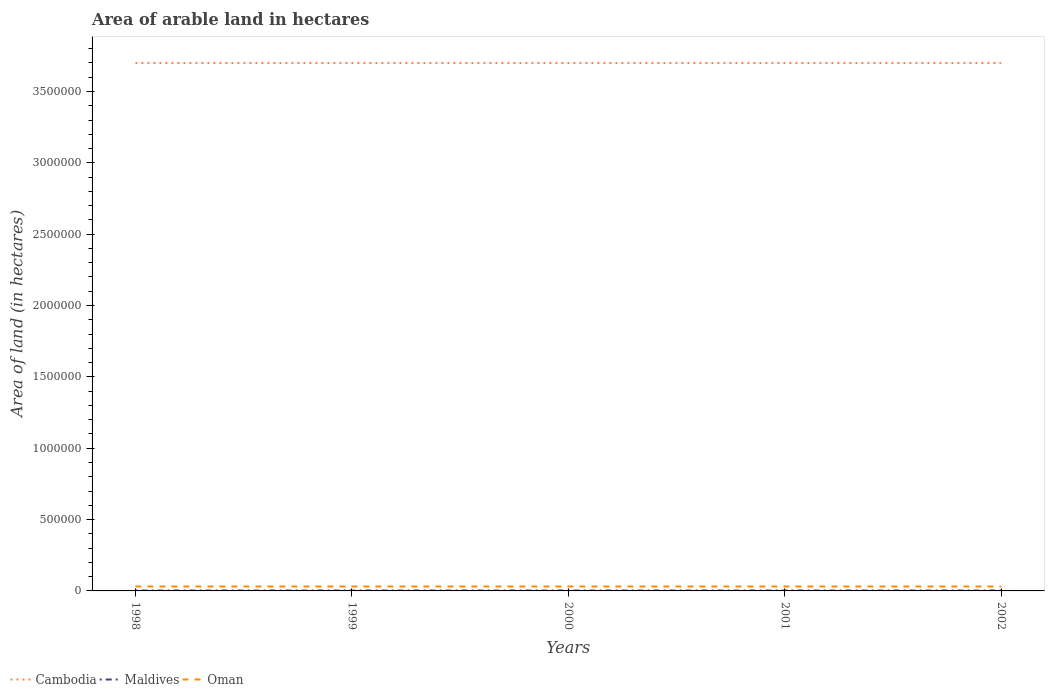Does the line corresponding to Maldives intersect with the line corresponding to Cambodia?
Make the answer very short. No. Is the number of lines equal to the number of legend labels?
Offer a terse response. Yes. Across all years, what is the maximum total arable land in Maldives?
Your answer should be compact. 3000. In which year was the total arable land in Oman maximum?
Provide a short and direct response. 1998. What is the difference between the highest and the second highest total arable land in Maldives?
Ensure brevity in your answer.  0. What is the difference between the highest and the lowest total arable land in Cambodia?
Your answer should be very brief. 0. Is the total arable land in Maldives strictly greater than the total arable land in Oman over the years?
Give a very brief answer. Yes. How many lines are there?
Provide a succinct answer. 3. How many years are there in the graph?
Make the answer very short. 5. What is the difference between two consecutive major ticks on the Y-axis?
Keep it short and to the point. 5.00e+05. Are the values on the major ticks of Y-axis written in scientific E-notation?
Give a very brief answer. No. Where does the legend appear in the graph?
Ensure brevity in your answer.  Bottom left. What is the title of the graph?
Provide a succinct answer. Area of arable land in hectares. What is the label or title of the X-axis?
Provide a short and direct response. Years. What is the label or title of the Y-axis?
Offer a very short reply. Area of land (in hectares). What is the Area of land (in hectares) in Cambodia in 1998?
Provide a succinct answer. 3.70e+06. What is the Area of land (in hectares) in Maldives in 1998?
Give a very brief answer. 3000. What is the Area of land (in hectares) of Oman in 1998?
Offer a very short reply. 3.10e+04. What is the Area of land (in hectares) in Cambodia in 1999?
Make the answer very short. 3.70e+06. What is the Area of land (in hectares) of Maldives in 1999?
Provide a short and direct response. 3000. What is the Area of land (in hectares) in Oman in 1999?
Make the answer very short. 3.10e+04. What is the Area of land (in hectares) of Cambodia in 2000?
Offer a very short reply. 3.70e+06. What is the Area of land (in hectares) of Maldives in 2000?
Give a very brief answer. 3000. What is the Area of land (in hectares) of Oman in 2000?
Your answer should be compact. 3.10e+04. What is the Area of land (in hectares) of Cambodia in 2001?
Provide a succinct answer. 3.70e+06. What is the Area of land (in hectares) in Maldives in 2001?
Ensure brevity in your answer.  3000. What is the Area of land (in hectares) in Oman in 2001?
Provide a succinct answer. 3.10e+04. What is the Area of land (in hectares) of Cambodia in 2002?
Offer a very short reply. 3.70e+06. What is the Area of land (in hectares) in Maldives in 2002?
Keep it short and to the point. 3000. What is the Area of land (in hectares) of Oman in 2002?
Your answer should be very brief. 3.10e+04. Across all years, what is the maximum Area of land (in hectares) in Cambodia?
Offer a very short reply. 3.70e+06. Across all years, what is the maximum Area of land (in hectares) in Maldives?
Provide a succinct answer. 3000. Across all years, what is the maximum Area of land (in hectares) in Oman?
Offer a very short reply. 3.10e+04. Across all years, what is the minimum Area of land (in hectares) of Cambodia?
Give a very brief answer. 3.70e+06. Across all years, what is the minimum Area of land (in hectares) in Maldives?
Your answer should be compact. 3000. Across all years, what is the minimum Area of land (in hectares) in Oman?
Your answer should be compact. 3.10e+04. What is the total Area of land (in hectares) in Cambodia in the graph?
Offer a very short reply. 1.85e+07. What is the total Area of land (in hectares) in Maldives in the graph?
Ensure brevity in your answer.  1.50e+04. What is the total Area of land (in hectares) of Oman in the graph?
Provide a short and direct response. 1.55e+05. What is the difference between the Area of land (in hectares) of Cambodia in 1998 and that in 1999?
Your answer should be very brief. 0. What is the difference between the Area of land (in hectares) in Maldives in 1998 and that in 1999?
Keep it short and to the point. 0. What is the difference between the Area of land (in hectares) of Cambodia in 1998 and that in 2000?
Offer a terse response. 0. What is the difference between the Area of land (in hectares) in Maldives in 1998 and that in 2000?
Your answer should be very brief. 0. What is the difference between the Area of land (in hectares) in Cambodia in 1998 and that in 2001?
Your response must be concise. 0. What is the difference between the Area of land (in hectares) in Maldives in 1998 and that in 2001?
Give a very brief answer. 0. What is the difference between the Area of land (in hectares) in Oman in 1998 and that in 2001?
Offer a terse response. 0. What is the difference between the Area of land (in hectares) of Cambodia in 1999 and that in 2000?
Give a very brief answer. 0. What is the difference between the Area of land (in hectares) of Oman in 1999 and that in 2000?
Offer a terse response. 0. What is the difference between the Area of land (in hectares) of Maldives in 1999 and that in 2001?
Ensure brevity in your answer.  0. What is the difference between the Area of land (in hectares) of Maldives in 1999 and that in 2002?
Provide a succinct answer. 0. What is the difference between the Area of land (in hectares) in Cambodia in 2000 and that in 2001?
Your answer should be very brief. 0. What is the difference between the Area of land (in hectares) of Maldives in 2000 and that in 2001?
Provide a succinct answer. 0. What is the difference between the Area of land (in hectares) in Oman in 2000 and that in 2002?
Your answer should be compact. 0. What is the difference between the Area of land (in hectares) in Cambodia in 1998 and the Area of land (in hectares) in Maldives in 1999?
Offer a very short reply. 3.70e+06. What is the difference between the Area of land (in hectares) of Cambodia in 1998 and the Area of land (in hectares) of Oman in 1999?
Give a very brief answer. 3.67e+06. What is the difference between the Area of land (in hectares) of Maldives in 1998 and the Area of land (in hectares) of Oman in 1999?
Provide a succinct answer. -2.80e+04. What is the difference between the Area of land (in hectares) of Cambodia in 1998 and the Area of land (in hectares) of Maldives in 2000?
Keep it short and to the point. 3.70e+06. What is the difference between the Area of land (in hectares) in Cambodia in 1998 and the Area of land (in hectares) in Oman in 2000?
Offer a very short reply. 3.67e+06. What is the difference between the Area of land (in hectares) of Maldives in 1998 and the Area of land (in hectares) of Oman in 2000?
Your answer should be compact. -2.80e+04. What is the difference between the Area of land (in hectares) of Cambodia in 1998 and the Area of land (in hectares) of Maldives in 2001?
Provide a succinct answer. 3.70e+06. What is the difference between the Area of land (in hectares) in Cambodia in 1998 and the Area of land (in hectares) in Oman in 2001?
Your answer should be very brief. 3.67e+06. What is the difference between the Area of land (in hectares) in Maldives in 1998 and the Area of land (in hectares) in Oman in 2001?
Your answer should be very brief. -2.80e+04. What is the difference between the Area of land (in hectares) in Cambodia in 1998 and the Area of land (in hectares) in Maldives in 2002?
Offer a very short reply. 3.70e+06. What is the difference between the Area of land (in hectares) in Cambodia in 1998 and the Area of land (in hectares) in Oman in 2002?
Provide a succinct answer. 3.67e+06. What is the difference between the Area of land (in hectares) in Maldives in 1998 and the Area of land (in hectares) in Oman in 2002?
Provide a short and direct response. -2.80e+04. What is the difference between the Area of land (in hectares) in Cambodia in 1999 and the Area of land (in hectares) in Maldives in 2000?
Provide a succinct answer. 3.70e+06. What is the difference between the Area of land (in hectares) in Cambodia in 1999 and the Area of land (in hectares) in Oman in 2000?
Keep it short and to the point. 3.67e+06. What is the difference between the Area of land (in hectares) of Maldives in 1999 and the Area of land (in hectares) of Oman in 2000?
Keep it short and to the point. -2.80e+04. What is the difference between the Area of land (in hectares) in Cambodia in 1999 and the Area of land (in hectares) in Maldives in 2001?
Your response must be concise. 3.70e+06. What is the difference between the Area of land (in hectares) of Cambodia in 1999 and the Area of land (in hectares) of Oman in 2001?
Ensure brevity in your answer.  3.67e+06. What is the difference between the Area of land (in hectares) of Maldives in 1999 and the Area of land (in hectares) of Oman in 2001?
Make the answer very short. -2.80e+04. What is the difference between the Area of land (in hectares) in Cambodia in 1999 and the Area of land (in hectares) in Maldives in 2002?
Your response must be concise. 3.70e+06. What is the difference between the Area of land (in hectares) of Cambodia in 1999 and the Area of land (in hectares) of Oman in 2002?
Your response must be concise. 3.67e+06. What is the difference between the Area of land (in hectares) in Maldives in 1999 and the Area of land (in hectares) in Oman in 2002?
Give a very brief answer. -2.80e+04. What is the difference between the Area of land (in hectares) in Cambodia in 2000 and the Area of land (in hectares) in Maldives in 2001?
Offer a very short reply. 3.70e+06. What is the difference between the Area of land (in hectares) of Cambodia in 2000 and the Area of land (in hectares) of Oman in 2001?
Give a very brief answer. 3.67e+06. What is the difference between the Area of land (in hectares) of Maldives in 2000 and the Area of land (in hectares) of Oman in 2001?
Keep it short and to the point. -2.80e+04. What is the difference between the Area of land (in hectares) in Cambodia in 2000 and the Area of land (in hectares) in Maldives in 2002?
Provide a short and direct response. 3.70e+06. What is the difference between the Area of land (in hectares) of Cambodia in 2000 and the Area of land (in hectares) of Oman in 2002?
Your answer should be very brief. 3.67e+06. What is the difference between the Area of land (in hectares) in Maldives in 2000 and the Area of land (in hectares) in Oman in 2002?
Offer a terse response. -2.80e+04. What is the difference between the Area of land (in hectares) of Cambodia in 2001 and the Area of land (in hectares) of Maldives in 2002?
Offer a terse response. 3.70e+06. What is the difference between the Area of land (in hectares) of Cambodia in 2001 and the Area of land (in hectares) of Oman in 2002?
Provide a short and direct response. 3.67e+06. What is the difference between the Area of land (in hectares) in Maldives in 2001 and the Area of land (in hectares) in Oman in 2002?
Give a very brief answer. -2.80e+04. What is the average Area of land (in hectares) in Cambodia per year?
Ensure brevity in your answer.  3.70e+06. What is the average Area of land (in hectares) of Maldives per year?
Your response must be concise. 3000. What is the average Area of land (in hectares) in Oman per year?
Provide a succinct answer. 3.10e+04. In the year 1998, what is the difference between the Area of land (in hectares) in Cambodia and Area of land (in hectares) in Maldives?
Provide a succinct answer. 3.70e+06. In the year 1998, what is the difference between the Area of land (in hectares) of Cambodia and Area of land (in hectares) of Oman?
Provide a short and direct response. 3.67e+06. In the year 1998, what is the difference between the Area of land (in hectares) of Maldives and Area of land (in hectares) of Oman?
Offer a very short reply. -2.80e+04. In the year 1999, what is the difference between the Area of land (in hectares) in Cambodia and Area of land (in hectares) in Maldives?
Give a very brief answer. 3.70e+06. In the year 1999, what is the difference between the Area of land (in hectares) of Cambodia and Area of land (in hectares) of Oman?
Your answer should be very brief. 3.67e+06. In the year 1999, what is the difference between the Area of land (in hectares) in Maldives and Area of land (in hectares) in Oman?
Provide a short and direct response. -2.80e+04. In the year 2000, what is the difference between the Area of land (in hectares) of Cambodia and Area of land (in hectares) of Maldives?
Make the answer very short. 3.70e+06. In the year 2000, what is the difference between the Area of land (in hectares) in Cambodia and Area of land (in hectares) in Oman?
Make the answer very short. 3.67e+06. In the year 2000, what is the difference between the Area of land (in hectares) of Maldives and Area of land (in hectares) of Oman?
Make the answer very short. -2.80e+04. In the year 2001, what is the difference between the Area of land (in hectares) in Cambodia and Area of land (in hectares) in Maldives?
Your answer should be compact. 3.70e+06. In the year 2001, what is the difference between the Area of land (in hectares) in Cambodia and Area of land (in hectares) in Oman?
Your answer should be very brief. 3.67e+06. In the year 2001, what is the difference between the Area of land (in hectares) of Maldives and Area of land (in hectares) of Oman?
Offer a very short reply. -2.80e+04. In the year 2002, what is the difference between the Area of land (in hectares) of Cambodia and Area of land (in hectares) of Maldives?
Make the answer very short. 3.70e+06. In the year 2002, what is the difference between the Area of land (in hectares) in Cambodia and Area of land (in hectares) in Oman?
Make the answer very short. 3.67e+06. In the year 2002, what is the difference between the Area of land (in hectares) of Maldives and Area of land (in hectares) of Oman?
Offer a very short reply. -2.80e+04. What is the ratio of the Area of land (in hectares) in Oman in 1998 to that in 1999?
Offer a terse response. 1. What is the ratio of the Area of land (in hectares) of Cambodia in 1998 to that in 2000?
Give a very brief answer. 1. What is the ratio of the Area of land (in hectares) of Oman in 1998 to that in 2001?
Offer a terse response. 1. What is the ratio of the Area of land (in hectares) in Oman in 1998 to that in 2002?
Your answer should be compact. 1. What is the ratio of the Area of land (in hectares) in Cambodia in 1999 to that in 2000?
Offer a very short reply. 1. What is the ratio of the Area of land (in hectares) in Oman in 1999 to that in 2000?
Ensure brevity in your answer.  1. What is the ratio of the Area of land (in hectares) of Cambodia in 1999 to that in 2002?
Your response must be concise. 1. What is the ratio of the Area of land (in hectares) in Cambodia in 2000 to that in 2001?
Ensure brevity in your answer.  1. What is the ratio of the Area of land (in hectares) in Maldives in 2000 to that in 2001?
Your response must be concise. 1. What is the ratio of the Area of land (in hectares) in Oman in 2000 to that in 2001?
Offer a terse response. 1. What is the ratio of the Area of land (in hectares) in Cambodia in 2001 to that in 2002?
Your answer should be very brief. 1. What is the difference between the highest and the lowest Area of land (in hectares) in Cambodia?
Offer a terse response. 0. 